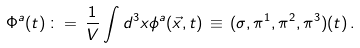<formula> <loc_0><loc_0><loc_500><loc_500>\Phi ^ { a } ( t ) \, \colon = \, \frac { 1 } { V } \int d ^ { 3 } x \phi ^ { a } ( \vec { x } , t ) \, \equiv \, ( \sigma , \pi ^ { 1 } , \pi ^ { 2 } , \pi ^ { 3 } ) ( t ) \, .</formula> 